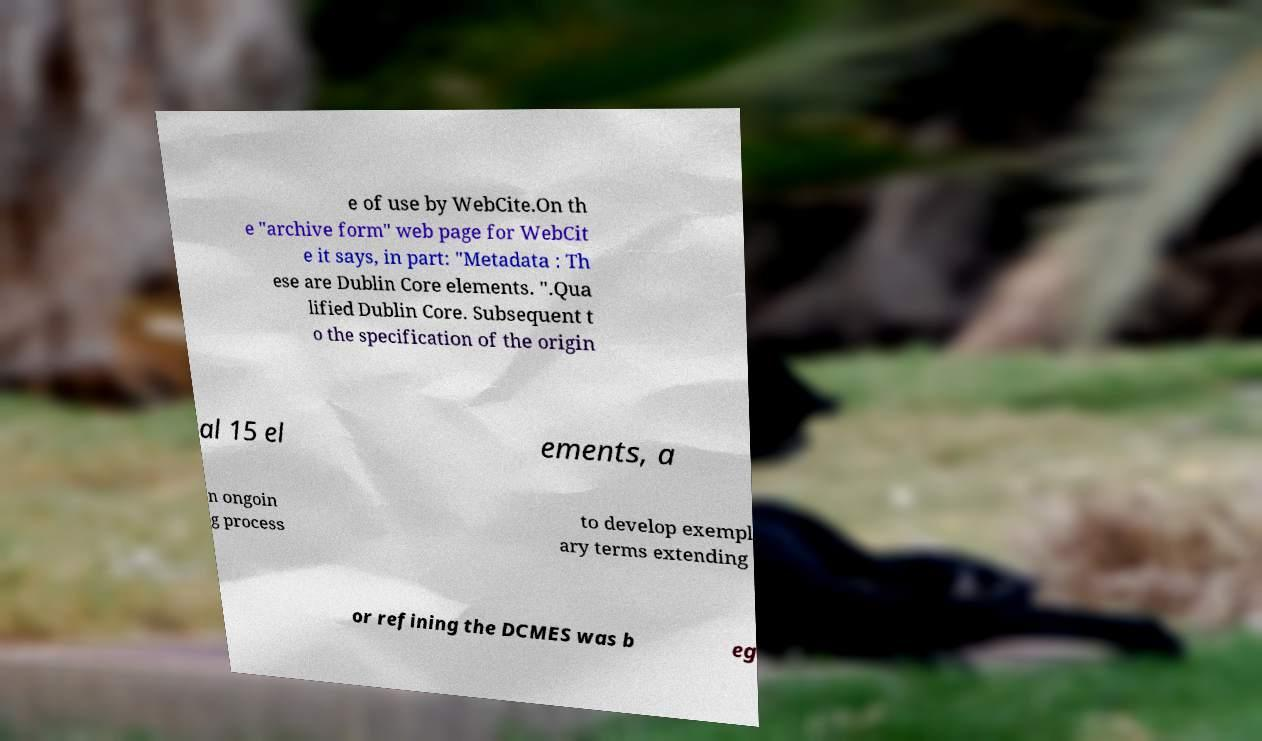Could you extract and type out the text from this image? e of use by WebCite.On th e "archive form" web page for WebCit e it says, in part: "Metadata : Th ese are Dublin Core elements. ".Qua lified Dublin Core. Subsequent t o the specification of the origin al 15 el ements, a n ongoin g process to develop exempl ary terms extending or refining the DCMES was b eg 